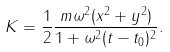Convert formula to latex. <formula><loc_0><loc_0><loc_500><loc_500>K = \frac { 1 } { 2 } \frac { m \omega ^ { 2 } ( x ^ { 2 } + y ^ { 2 } ) } { 1 + \omega ^ { 2 } ( t - t _ { 0 } ) ^ { 2 } } .</formula> 